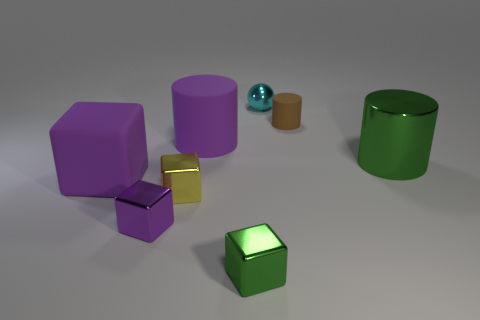There is a green thing in front of the small purple block; is its shape the same as the cyan object?
Provide a short and direct response. No. There is a small purple object that is the same shape as the tiny yellow shiny object; what is its material?
Ensure brevity in your answer.  Metal. What number of green cylinders are the same size as the cyan ball?
Provide a succinct answer. 0. The shiny thing that is both right of the small green cube and in front of the ball is what color?
Make the answer very short. Green. Is the number of large red shiny things less than the number of brown cylinders?
Offer a very short reply. Yes. Does the shiny sphere have the same color as the cylinder that is right of the tiny brown matte cylinder?
Give a very brief answer. No. Are there an equal number of purple rubber cylinders behind the sphere and big green objects that are right of the green metal cylinder?
Offer a very short reply. Yes. What number of other purple objects have the same shape as the big shiny object?
Give a very brief answer. 1. Is there a large matte thing?
Your response must be concise. Yes. Does the small brown cylinder have the same material as the purple cube that is in front of the tiny yellow thing?
Give a very brief answer. No. 